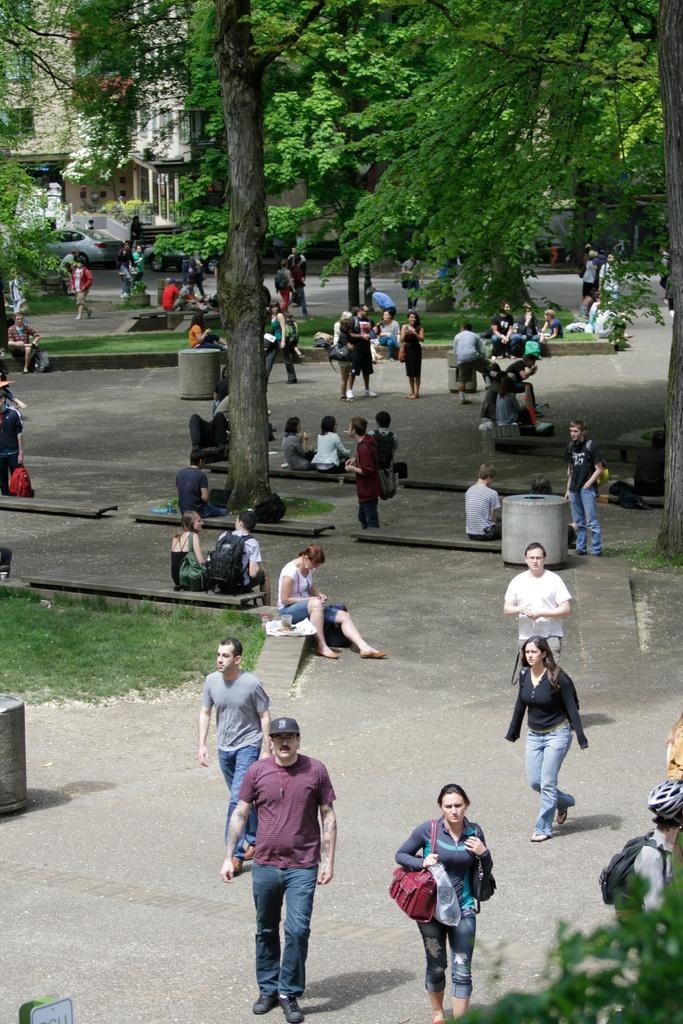In one or two sentences, can you explain what this image depicts? In this picture there are group of people, few people are walking and few people are standing and few people are sitting. At the back there is a building and there are trees and there is a vehicle. At the bottom there is a road and there is grass. 